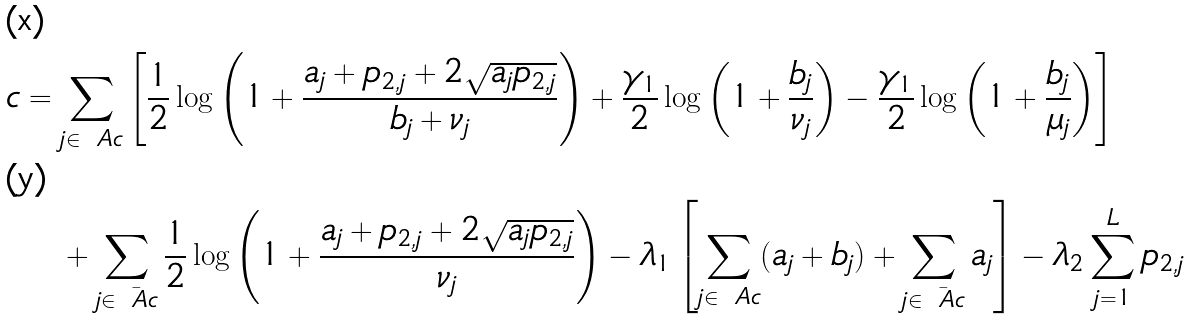<formula> <loc_0><loc_0><loc_500><loc_500>\L c & = \sum _ { j \in \ A c } \left [ \frac { 1 } { 2 } \log \left ( 1 + \frac { a _ { j } + p _ { 2 , j } + 2 \sqrt { a _ { j } p _ { 2 , j } } } { b _ { j } + \nu _ { j } } \right ) + \frac { \gamma _ { 1 } } { 2 } \log \left ( 1 + \frac { b _ { j } } { \nu _ { j } } \right ) - \frac { \gamma _ { 1 } } { 2 } \log \left ( 1 + \frac { b _ { j } } { \mu _ { j } } \right ) \right ] \\ & \quad + \sum _ { j \in \bar { \ A c } } \frac { 1 } { 2 } \log \left ( 1 + \frac { a _ { j } + p _ { 2 , j } + 2 \sqrt { a _ { j } p _ { 2 , j } } } { \nu _ { j } } \right ) - \lambda _ { 1 } \left [ \sum _ { j \in \ A c } ( a _ { j } + b _ { j } ) + \sum _ { j \in \bar { \ A c } } a _ { j } \right ] - \lambda _ { 2 } \sum _ { j = 1 } ^ { L } p _ { 2 , j }</formula> 